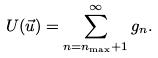<formula> <loc_0><loc_0><loc_500><loc_500>U ( \vec { u } ) = \sum _ { n = n _ { \max } + 1 } ^ { \infty } g _ { n } .</formula> 